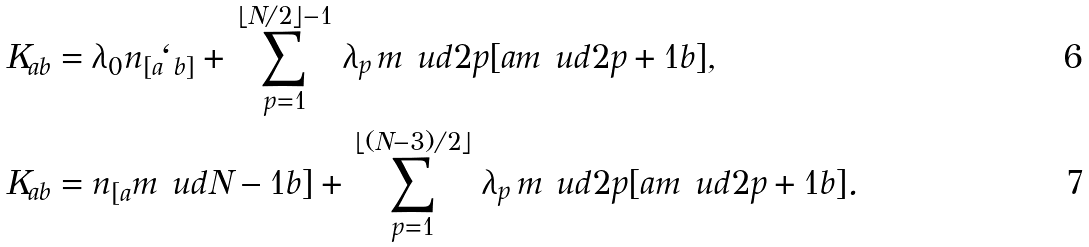<formula> <loc_0><loc_0><loc_500><loc_500>K _ { a b } & = \lambda _ { 0 } n _ { [ a } \ell _ { b ] } + \, \sum _ { p = 1 } ^ { \lfloor N / 2 \rfloor - 1 } \, \lambda _ { p } \, m \ u d { 2 p } { [ a } m \ u d { 2 p + 1 } { b ] } , \\ K _ { a b } & = n _ { [ a } m \ u d { N - 1 } { b ] } + \, \sum _ { p = 1 } ^ { \lfloor ( N - 3 ) / 2 \rfloor } \, \lambda _ { p } \, m \ u d { 2 p } { [ a } m \ u d { 2 p + 1 } { b ] } .</formula> 